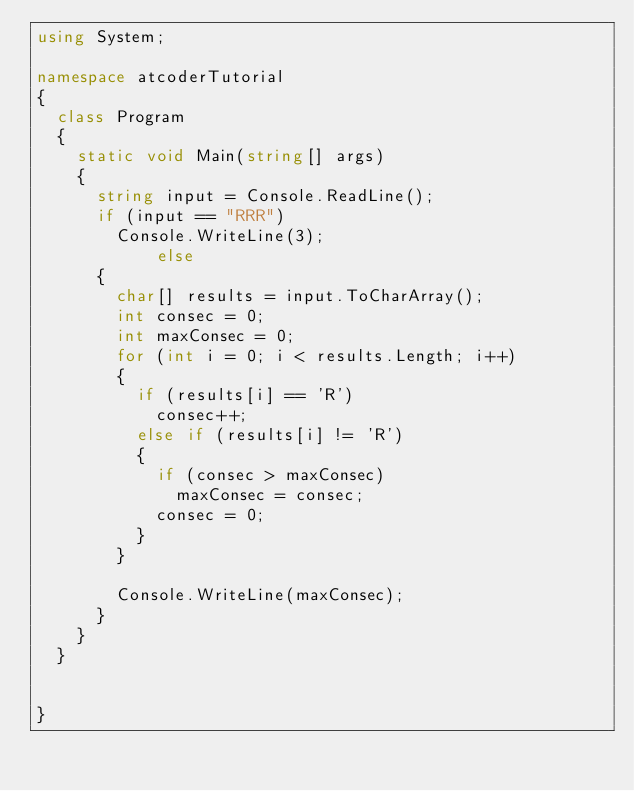Convert code to text. <code><loc_0><loc_0><loc_500><loc_500><_C#_>using System;

namespace atcoderTutorial
{
	class Program
	{
		static void Main(string[] args)
		{
			string input = Console.ReadLine();
			if (input == "RRR")
				Console.WriteLine(3);
            else
			{
				char[] results = input.ToCharArray();
				int consec = 0;
				int maxConsec = 0;
				for (int i = 0; i < results.Length; i++)
				{
					if (results[i] == 'R')
						consec++;
					else if (results[i] != 'R')
					{
						if (consec > maxConsec)
							maxConsec = consec;
						consec = 0;
					}
				}

				Console.WriteLine(maxConsec);
			}
		}
	}

	
}
</code> 